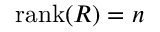<formula> <loc_0><loc_0><loc_500><loc_500>r a n k ( R ) = n</formula> 